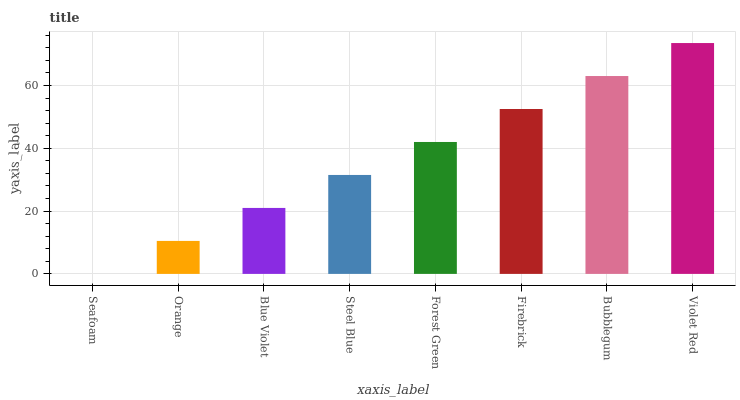Is Seafoam the minimum?
Answer yes or no. Yes. Is Violet Red the maximum?
Answer yes or no. Yes. Is Orange the minimum?
Answer yes or no. No. Is Orange the maximum?
Answer yes or no. No. Is Orange greater than Seafoam?
Answer yes or no. Yes. Is Seafoam less than Orange?
Answer yes or no. Yes. Is Seafoam greater than Orange?
Answer yes or no. No. Is Orange less than Seafoam?
Answer yes or no. No. Is Forest Green the high median?
Answer yes or no. Yes. Is Steel Blue the low median?
Answer yes or no. Yes. Is Orange the high median?
Answer yes or no. No. Is Forest Green the low median?
Answer yes or no. No. 